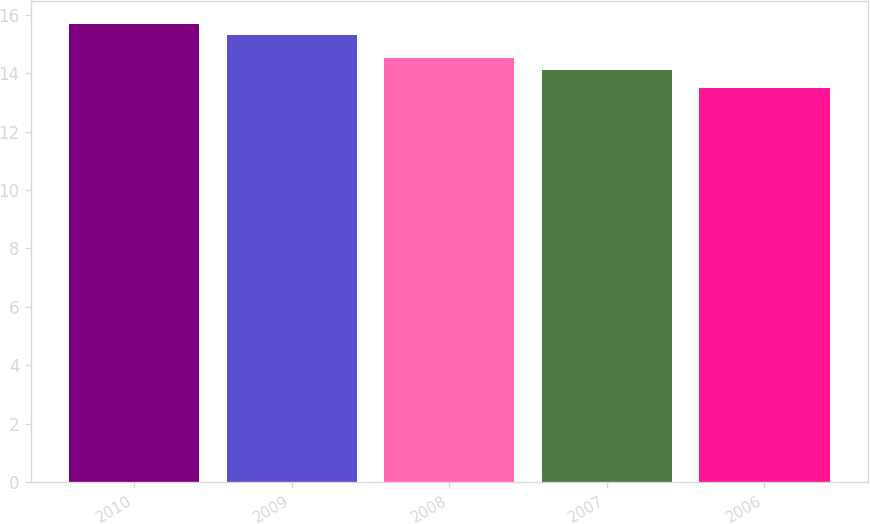Convert chart to OTSL. <chart><loc_0><loc_0><loc_500><loc_500><bar_chart><fcel>2010<fcel>2009<fcel>2008<fcel>2007<fcel>2006<nl><fcel>15.68<fcel>15.3<fcel>14.52<fcel>14.12<fcel>13.48<nl></chart> 